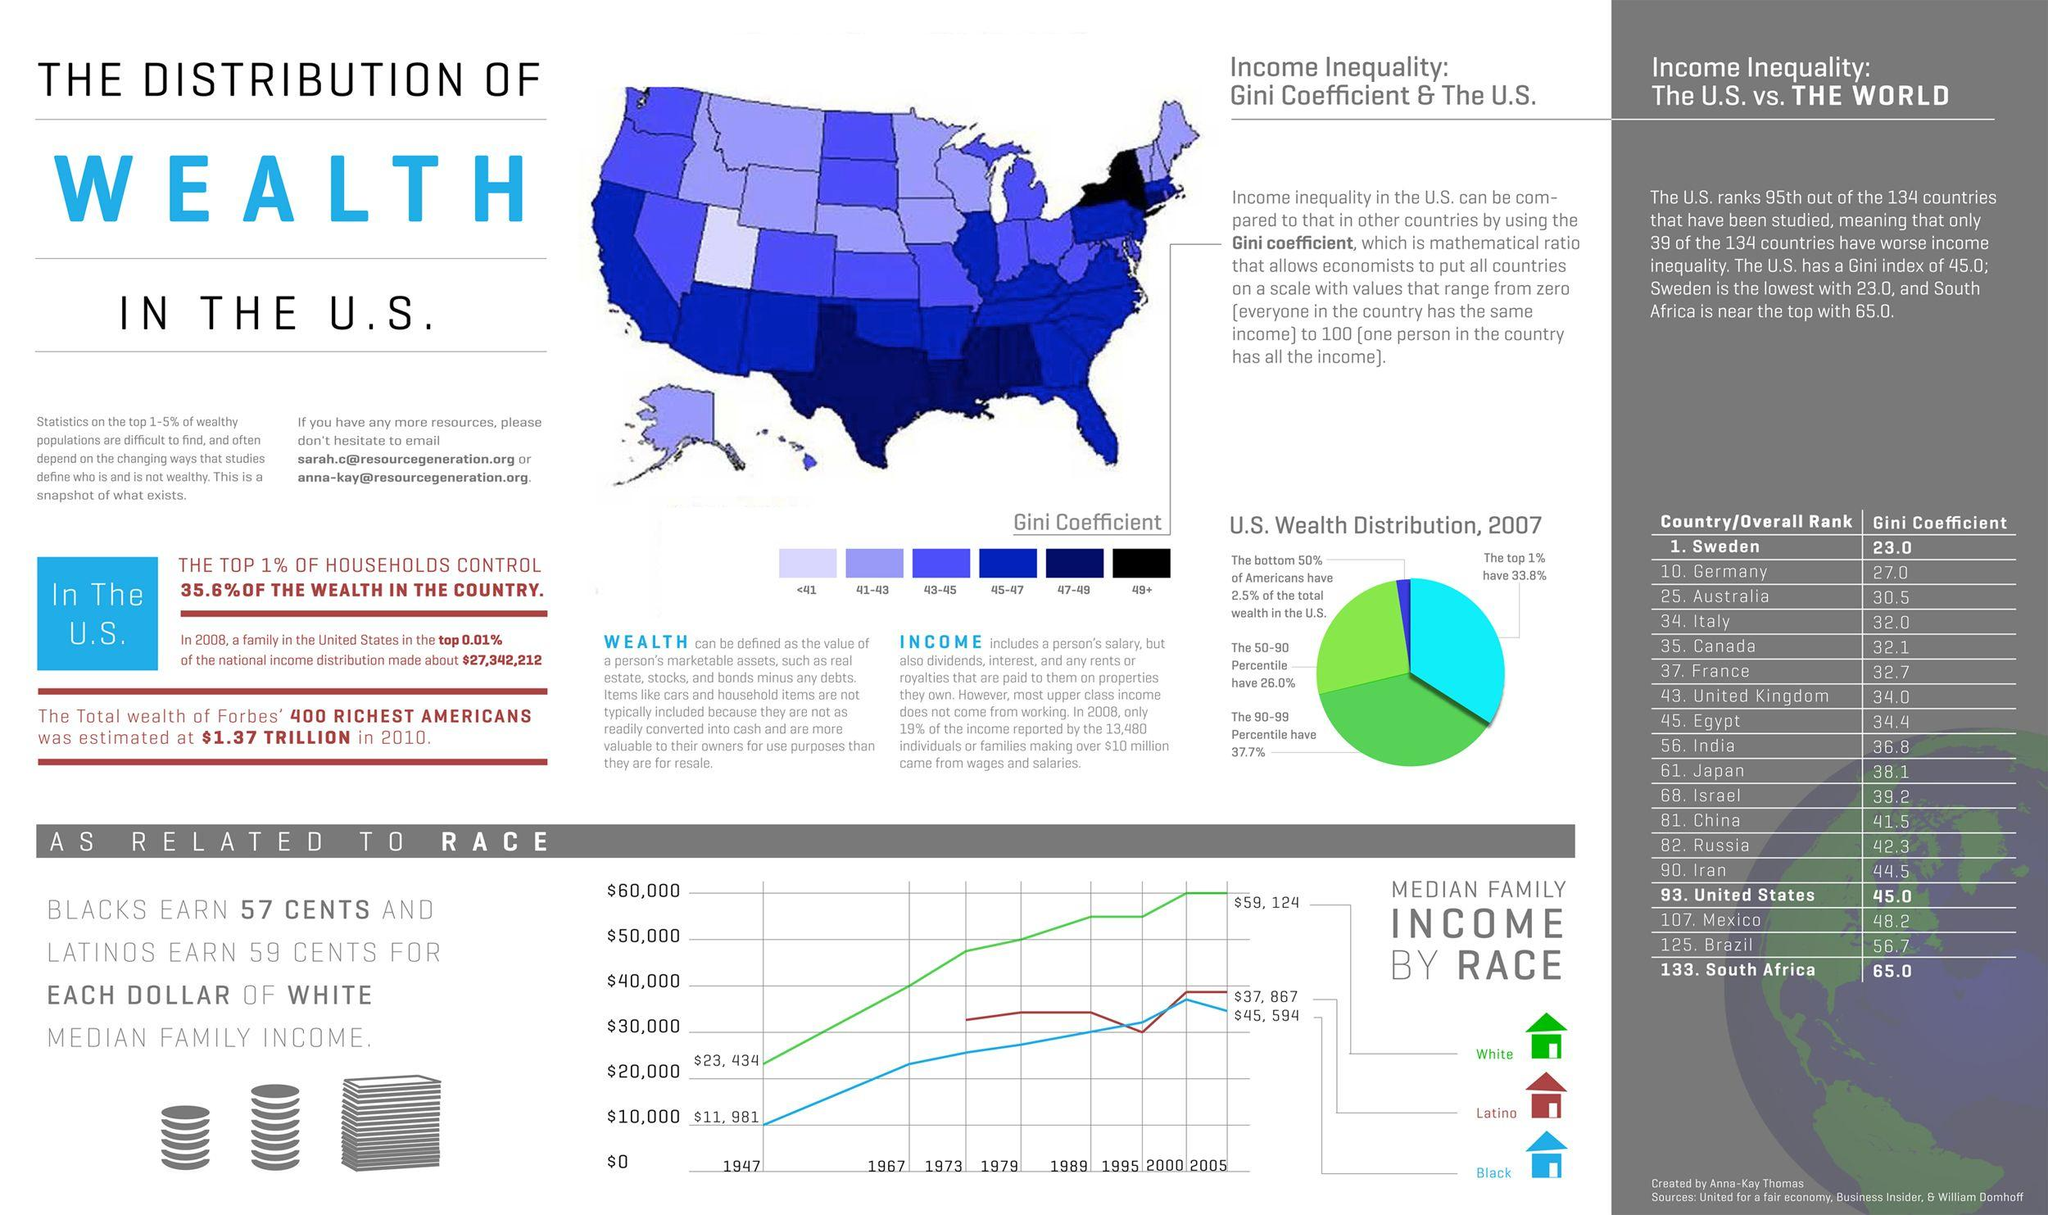Highlight a few significant elements in this photo. According to a study of 134 countries, Germany has the tenth lowest Gini coefficient, which is a measure of income inequality. A total of 44 countries have higher levels of income inequality than Iran out of the 134 countries that have been studied. According to a study of 134 countries, there are more countries with higher income inequality than South Africa. Out of the 134 countries that have been studied, 99 have worse income inequality than Canada. Out of the 134 countries that have been studied, 9 have worse income inequality than Brazil. 